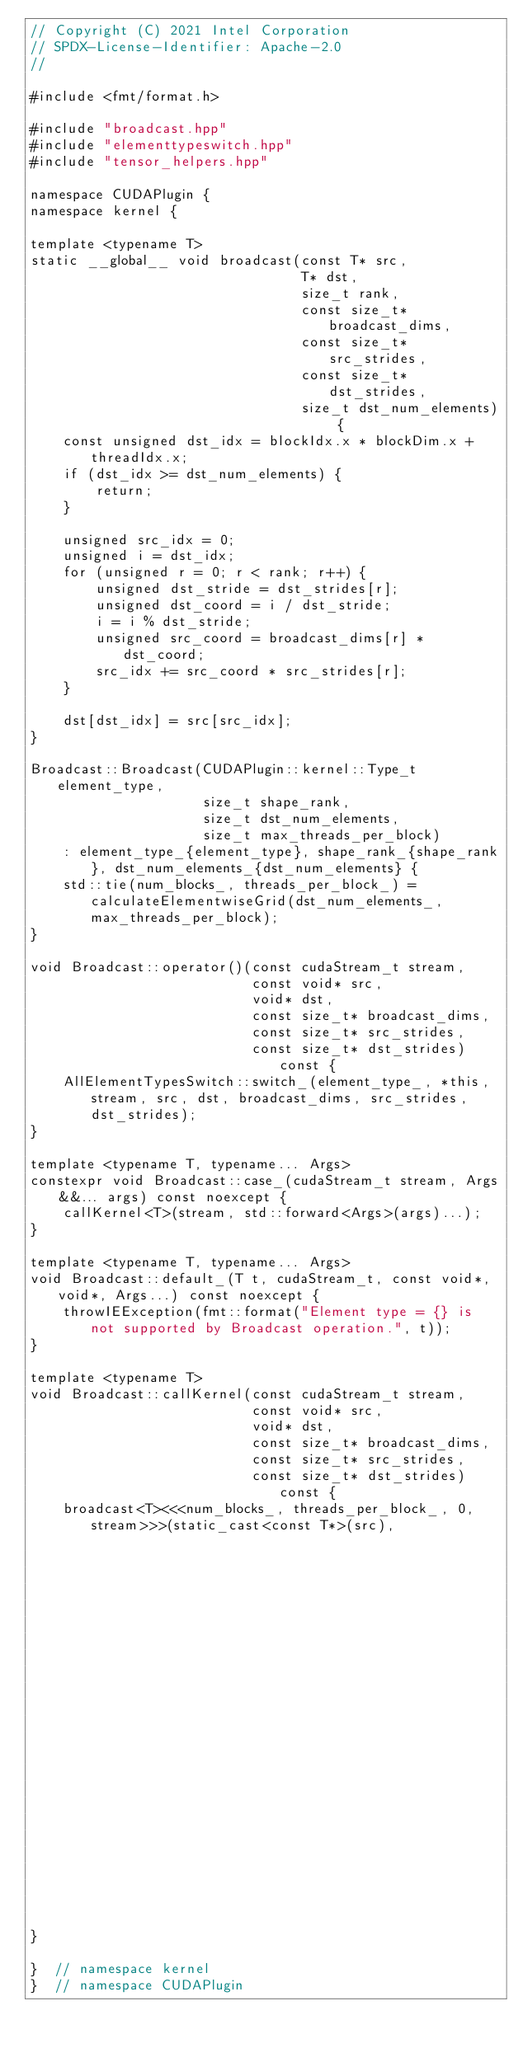<code> <loc_0><loc_0><loc_500><loc_500><_Cuda_>// Copyright (C) 2021 Intel Corporation
// SPDX-License-Identifier: Apache-2.0
//

#include <fmt/format.h>

#include "broadcast.hpp"
#include "elementtypeswitch.hpp"
#include "tensor_helpers.hpp"

namespace CUDAPlugin {
namespace kernel {

template <typename T>
static __global__ void broadcast(const T* src,
                                 T* dst,
                                 size_t rank,
                                 const size_t* broadcast_dims,
                                 const size_t* src_strides,
                                 const size_t* dst_strides,
                                 size_t dst_num_elements) {
    const unsigned dst_idx = blockIdx.x * blockDim.x + threadIdx.x;
    if (dst_idx >= dst_num_elements) {
        return;
    }

    unsigned src_idx = 0;
    unsigned i = dst_idx;
    for (unsigned r = 0; r < rank; r++) {
        unsigned dst_stride = dst_strides[r];
        unsigned dst_coord = i / dst_stride;
        i = i % dst_stride;
        unsigned src_coord = broadcast_dims[r] * dst_coord;
        src_idx += src_coord * src_strides[r];
    }

    dst[dst_idx] = src[src_idx];
}

Broadcast::Broadcast(CUDAPlugin::kernel::Type_t element_type,
                     size_t shape_rank,
                     size_t dst_num_elements,
                     size_t max_threads_per_block)
    : element_type_{element_type}, shape_rank_{shape_rank}, dst_num_elements_{dst_num_elements} {
    std::tie(num_blocks_, threads_per_block_) = calculateElementwiseGrid(dst_num_elements_, max_threads_per_block);
}

void Broadcast::operator()(const cudaStream_t stream,
                           const void* src,
                           void* dst,
                           const size_t* broadcast_dims,
                           const size_t* src_strides,
                           const size_t* dst_strides) const {
    AllElementTypesSwitch::switch_(element_type_, *this, stream, src, dst, broadcast_dims, src_strides, dst_strides);
}

template <typename T, typename... Args>
constexpr void Broadcast::case_(cudaStream_t stream, Args&&... args) const noexcept {
    callKernel<T>(stream, std::forward<Args>(args)...);
}

template <typename T, typename... Args>
void Broadcast::default_(T t, cudaStream_t, const void*, void*, Args...) const noexcept {
    throwIEException(fmt::format("Element type = {} is not supported by Broadcast operation.", t));
}

template <typename T>
void Broadcast::callKernel(const cudaStream_t stream,
                           const void* src,
                           void* dst,
                           const size_t* broadcast_dims,
                           const size_t* src_strides,
                           const size_t* dst_strides) const {
    broadcast<T><<<num_blocks_, threads_per_block_, 0, stream>>>(static_cast<const T*>(src),
                                                                 static_cast<T*>(dst),
                                                                 shape_rank_,
                                                                 broadcast_dims,
                                                                 src_strides,
                                                                 dst_strides,
                                                                 dst_num_elements_);
}

}  // namespace kernel
}  // namespace CUDAPlugin
</code> 